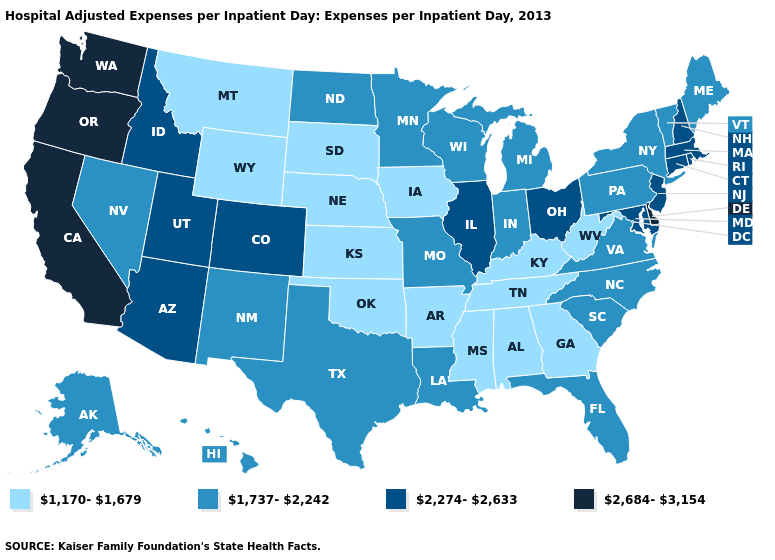What is the value of North Dakota?
Quick response, please. 1,737-2,242. What is the value of Colorado?
Be succinct. 2,274-2,633. What is the highest value in the MidWest ?
Quick response, please. 2,274-2,633. What is the value of Virginia?
Keep it brief. 1,737-2,242. Among the states that border Wyoming , which have the highest value?
Give a very brief answer. Colorado, Idaho, Utah. Does Delaware have the highest value in the South?
Keep it brief. Yes. What is the value of Oregon?
Answer briefly. 2,684-3,154. Among the states that border Iowa , does Missouri have the lowest value?
Keep it brief. No. How many symbols are there in the legend?
Concise answer only. 4. Which states hav the highest value in the Northeast?
Answer briefly. Connecticut, Massachusetts, New Hampshire, New Jersey, Rhode Island. What is the lowest value in states that border Wyoming?
Be succinct. 1,170-1,679. What is the lowest value in the USA?
Quick response, please. 1,170-1,679. Which states have the highest value in the USA?
Write a very short answer. California, Delaware, Oregon, Washington. Which states have the lowest value in the West?
Concise answer only. Montana, Wyoming. 